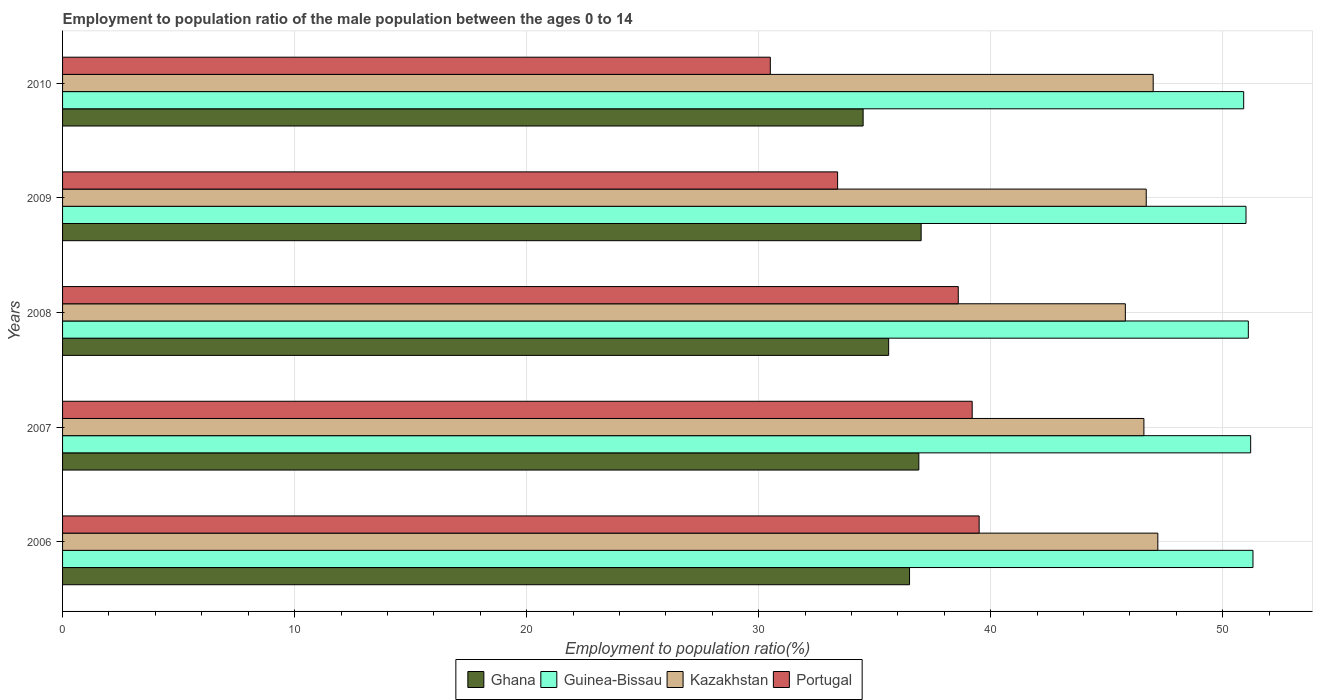How many bars are there on the 4th tick from the bottom?
Your answer should be compact. 4. What is the label of the 3rd group of bars from the top?
Your answer should be compact. 2008. What is the employment to population ratio in Ghana in 2010?
Keep it short and to the point. 34.5. Across all years, what is the maximum employment to population ratio in Ghana?
Your answer should be very brief. 37. Across all years, what is the minimum employment to population ratio in Kazakhstan?
Your answer should be compact. 45.8. In which year was the employment to population ratio in Kazakhstan maximum?
Offer a very short reply. 2006. What is the total employment to population ratio in Portugal in the graph?
Your answer should be compact. 181.2. What is the difference between the employment to population ratio in Guinea-Bissau in 2007 and that in 2008?
Give a very brief answer. 0.1. What is the difference between the employment to population ratio in Kazakhstan in 2009 and the employment to population ratio in Portugal in 2007?
Offer a terse response. 7.5. What is the average employment to population ratio in Portugal per year?
Ensure brevity in your answer.  36.24. In the year 2007, what is the difference between the employment to population ratio in Ghana and employment to population ratio in Kazakhstan?
Make the answer very short. -9.7. In how many years, is the employment to population ratio in Kazakhstan greater than 44 %?
Provide a succinct answer. 5. What is the ratio of the employment to population ratio in Kazakhstan in 2007 to that in 2010?
Give a very brief answer. 0.99. Is the difference between the employment to population ratio in Ghana in 2006 and 2010 greater than the difference between the employment to population ratio in Kazakhstan in 2006 and 2010?
Make the answer very short. Yes. What is the difference between the highest and the second highest employment to population ratio in Kazakhstan?
Keep it short and to the point. 0.2. What is the difference between the highest and the lowest employment to population ratio in Guinea-Bissau?
Your response must be concise. 0.4. Is it the case that in every year, the sum of the employment to population ratio in Portugal and employment to population ratio in Kazakhstan is greater than the sum of employment to population ratio in Guinea-Bissau and employment to population ratio in Ghana?
Your answer should be compact. No. What does the 3rd bar from the bottom in 2007 represents?
Give a very brief answer. Kazakhstan. Is it the case that in every year, the sum of the employment to population ratio in Kazakhstan and employment to population ratio in Guinea-Bissau is greater than the employment to population ratio in Portugal?
Your answer should be very brief. Yes. How many bars are there?
Your answer should be compact. 20. What is the difference between two consecutive major ticks on the X-axis?
Keep it short and to the point. 10. Does the graph contain any zero values?
Provide a short and direct response. No. Where does the legend appear in the graph?
Your response must be concise. Bottom center. How many legend labels are there?
Make the answer very short. 4. How are the legend labels stacked?
Give a very brief answer. Horizontal. What is the title of the graph?
Your answer should be compact. Employment to population ratio of the male population between the ages 0 to 14. Does "Fragile and conflict affected situations" appear as one of the legend labels in the graph?
Offer a terse response. No. What is the label or title of the X-axis?
Keep it short and to the point. Employment to population ratio(%). What is the Employment to population ratio(%) of Ghana in 2006?
Offer a very short reply. 36.5. What is the Employment to population ratio(%) of Guinea-Bissau in 2006?
Make the answer very short. 51.3. What is the Employment to population ratio(%) in Kazakhstan in 2006?
Keep it short and to the point. 47.2. What is the Employment to population ratio(%) of Portugal in 2006?
Keep it short and to the point. 39.5. What is the Employment to population ratio(%) in Ghana in 2007?
Your response must be concise. 36.9. What is the Employment to population ratio(%) of Guinea-Bissau in 2007?
Offer a very short reply. 51.2. What is the Employment to population ratio(%) of Kazakhstan in 2007?
Give a very brief answer. 46.6. What is the Employment to population ratio(%) in Portugal in 2007?
Offer a very short reply. 39.2. What is the Employment to population ratio(%) in Ghana in 2008?
Make the answer very short. 35.6. What is the Employment to population ratio(%) in Guinea-Bissau in 2008?
Provide a succinct answer. 51.1. What is the Employment to population ratio(%) in Kazakhstan in 2008?
Your response must be concise. 45.8. What is the Employment to population ratio(%) of Portugal in 2008?
Make the answer very short. 38.6. What is the Employment to population ratio(%) in Ghana in 2009?
Your answer should be very brief. 37. What is the Employment to population ratio(%) of Guinea-Bissau in 2009?
Your answer should be very brief. 51. What is the Employment to population ratio(%) of Kazakhstan in 2009?
Offer a terse response. 46.7. What is the Employment to population ratio(%) of Portugal in 2009?
Ensure brevity in your answer.  33.4. What is the Employment to population ratio(%) in Ghana in 2010?
Offer a very short reply. 34.5. What is the Employment to population ratio(%) in Guinea-Bissau in 2010?
Provide a succinct answer. 50.9. What is the Employment to population ratio(%) of Portugal in 2010?
Offer a terse response. 30.5. Across all years, what is the maximum Employment to population ratio(%) of Ghana?
Give a very brief answer. 37. Across all years, what is the maximum Employment to population ratio(%) of Guinea-Bissau?
Your answer should be compact. 51.3. Across all years, what is the maximum Employment to population ratio(%) in Kazakhstan?
Offer a terse response. 47.2. Across all years, what is the maximum Employment to population ratio(%) of Portugal?
Ensure brevity in your answer.  39.5. Across all years, what is the minimum Employment to population ratio(%) of Ghana?
Ensure brevity in your answer.  34.5. Across all years, what is the minimum Employment to population ratio(%) of Guinea-Bissau?
Your answer should be compact. 50.9. Across all years, what is the minimum Employment to population ratio(%) of Kazakhstan?
Your response must be concise. 45.8. Across all years, what is the minimum Employment to population ratio(%) in Portugal?
Ensure brevity in your answer.  30.5. What is the total Employment to population ratio(%) of Ghana in the graph?
Make the answer very short. 180.5. What is the total Employment to population ratio(%) of Guinea-Bissau in the graph?
Ensure brevity in your answer.  255.5. What is the total Employment to population ratio(%) of Kazakhstan in the graph?
Provide a succinct answer. 233.3. What is the total Employment to population ratio(%) in Portugal in the graph?
Ensure brevity in your answer.  181.2. What is the difference between the Employment to population ratio(%) of Ghana in 2006 and that in 2009?
Offer a very short reply. -0.5. What is the difference between the Employment to population ratio(%) in Guinea-Bissau in 2006 and that in 2009?
Keep it short and to the point. 0.3. What is the difference between the Employment to population ratio(%) of Portugal in 2006 and that in 2009?
Ensure brevity in your answer.  6.1. What is the difference between the Employment to population ratio(%) of Portugal in 2006 and that in 2010?
Offer a very short reply. 9. What is the difference between the Employment to population ratio(%) in Ghana in 2007 and that in 2008?
Make the answer very short. 1.3. What is the difference between the Employment to population ratio(%) in Kazakhstan in 2007 and that in 2008?
Provide a succinct answer. 0.8. What is the difference between the Employment to population ratio(%) in Portugal in 2007 and that in 2008?
Keep it short and to the point. 0.6. What is the difference between the Employment to population ratio(%) in Ghana in 2007 and that in 2009?
Provide a short and direct response. -0.1. What is the difference between the Employment to population ratio(%) of Guinea-Bissau in 2007 and that in 2009?
Your answer should be very brief. 0.2. What is the difference between the Employment to population ratio(%) of Portugal in 2007 and that in 2009?
Your answer should be compact. 5.8. What is the difference between the Employment to population ratio(%) in Ghana in 2007 and that in 2010?
Your answer should be very brief. 2.4. What is the difference between the Employment to population ratio(%) of Guinea-Bissau in 2007 and that in 2010?
Keep it short and to the point. 0.3. What is the difference between the Employment to population ratio(%) of Kazakhstan in 2007 and that in 2010?
Offer a very short reply. -0.4. What is the difference between the Employment to population ratio(%) in Portugal in 2007 and that in 2010?
Make the answer very short. 8.7. What is the difference between the Employment to population ratio(%) in Portugal in 2008 and that in 2009?
Your response must be concise. 5.2. What is the difference between the Employment to population ratio(%) of Kazakhstan in 2008 and that in 2010?
Offer a very short reply. -1.2. What is the difference between the Employment to population ratio(%) in Ghana in 2009 and that in 2010?
Your response must be concise. 2.5. What is the difference between the Employment to population ratio(%) in Guinea-Bissau in 2009 and that in 2010?
Provide a succinct answer. 0.1. What is the difference between the Employment to population ratio(%) in Ghana in 2006 and the Employment to population ratio(%) in Guinea-Bissau in 2007?
Offer a very short reply. -14.7. What is the difference between the Employment to population ratio(%) in Ghana in 2006 and the Employment to population ratio(%) in Kazakhstan in 2007?
Offer a terse response. -10.1. What is the difference between the Employment to population ratio(%) of Ghana in 2006 and the Employment to population ratio(%) of Portugal in 2007?
Make the answer very short. -2.7. What is the difference between the Employment to population ratio(%) in Kazakhstan in 2006 and the Employment to population ratio(%) in Portugal in 2007?
Make the answer very short. 8. What is the difference between the Employment to population ratio(%) in Ghana in 2006 and the Employment to population ratio(%) in Guinea-Bissau in 2008?
Offer a terse response. -14.6. What is the difference between the Employment to population ratio(%) of Ghana in 2006 and the Employment to population ratio(%) of Kazakhstan in 2008?
Ensure brevity in your answer.  -9.3. What is the difference between the Employment to population ratio(%) of Ghana in 2006 and the Employment to population ratio(%) of Portugal in 2008?
Offer a terse response. -2.1. What is the difference between the Employment to population ratio(%) in Ghana in 2006 and the Employment to population ratio(%) in Guinea-Bissau in 2009?
Offer a very short reply. -14.5. What is the difference between the Employment to population ratio(%) of Ghana in 2006 and the Employment to population ratio(%) of Portugal in 2009?
Keep it short and to the point. 3.1. What is the difference between the Employment to population ratio(%) in Guinea-Bissau in 2006 and the Employment to population ratio(%) in Portugal in 2009?
Provide a succinct answer. 17.9. What is the difference between the Employment to population ratio(%) of Kazakhstan in 2006 and the Employment to population ratio(%) of Portugal in 2009?
Provide a succinct answer. 13.8. What is the difference between the Employment to population ratio(%) of Ghana in 2006 and the Employment to population ratio(%) of Guinea-Bissau in 2010?
Make the answer very short. -14.4. What is the difference between the Employment to population ratio(%) in Guinea-Bissau in 2006 and the Employment to population ratio(%) in Portugal in 2010?
Your answer should be compact. 20.8. What is the difference between the Employment to population ratio(%) in Kazakhstan in 2006 and the Employment to population ratio(%) in Portugal in 2010?
Keep it short and to the point. 16.7. What is the difference between the Employment to population ratio(%) of Ghana in 2007 and the Employment to population ratio(%) of Kazakhstan in 2008?
Offer a terse response. -8.9. What is the difference between the Employment to population ratio(%) in Ghana in 2007 and the Employment to population ratio(%) in Portugal in 2008?
Your answer should be compact. -1.7. What is the difference between the Employment to population ratio(%) in Guinea-Bissau in 2007 and the Employment to population ratio(%) in Kazakhstan in 2008?
Make the answer very short. 5.4. What is the difference between the Employment to population ratio(%) of Kazakhstan in 2007 and the Employment to population ratio(%) of Portugal in 2008?
Provide a succinct answer. 8. What is the difference between the Employment to population ratio(%) of Ghana in 2007 and the Employment to population ratio(%) of Guinea-Bissau in 2009?
Give a very brief answer. -14.1. What is the difference between the Employment to population ratio(%) of Ghana in 2007 and the Employment to population ratio(%) of Portugal in 2009?
Make the answer very short. 3.5. What is the difference between the Employment to population ratio(%) in Guinea-Bissau in 2007 and the Employment to population ratio(%) in Portugal in 2009?
Offer a terse response. 17.8. What is the difference between the Employment to population ratio(%) in Ghana in 2007 and the Employment to population ratio(%) in Portugal in 2010?
Ensure brevity in your answer.  6.4. What is the difference between the Employment to population ratio(%) of Guinea-Bissau in 2007 and the Employment to population ratio(%) of Portugal in 2010?
Offer a terse response. 20.7. What is the difference between the Employment to population ratio(%) of Ghana in 2008 and the Employment to population ratio(%) of Guinea-Bissau in 2009?
Give a very brief answer. -15.4. What is the difference between the Employment to population ratio(%) of Ghana in 2008 and the Employment to population ratio(%) of Portugal in 2009?
Provide a succinct answer. 2.2. What is the difference between the Employment to population ratio(%) in Ghana in 2008 and the Employment to population ratio(%) in Guinea-Bissau in 2010?
Provide a succinct answer. -15.3. What is the difference between the Employment to population ratio(%) in Guinea-Bissau in 2008 and the Employment to population ratio(%) in Kazakhstan in 2010?
Provide a succinct answer. 4.1. What is the difference between the Employment to population ratio(%) in Guinea-Bissau in 2008 and the Employment to population ratio(%) in Portugal in 2010?
Keep it short and to the point. 20.6. What is the difference between the Employment to population ratio(%) in Ghana in 2009 and the Employment to population ratio(%) in Kazakhstan in 2010?
Your response must be concise. -10. What is the difference between the Employment to population ratio(%) of Guinea-Bissau in 2009 and the Employment to population ratio(%) of Kazakhstan in 2010?
Give a very brief answer. 4. What is the difference between the Employment to population ratio(%) in Kazakhstan in 2009 and the Employment to population ratio(%) in Portugal in 2010?
Give a very brief answer. 16.2. What is the average Employment to population ratio(%) of Ghana per year?
Provide a short and direct response. 36.1. What is the average Employment to population ratio(%) of Guinea-Bissau per year?
Give a very brief answer. 51.1. What is the average Employment to population ratio(%) in Kazakhstan per year?
Offer a terse response. 46.66. What is the average Employment to population ratio(%) in Portugal per year?
Make the answer very short. 36.24. In the year 2006, what is the difference between the Employment to population ratio(%) in Ghana and Employment to population ratio(%) in Guinea-Bissau?
Provide a succinct answer. -14.8. In the year 2006, what is the difference between the Employment to population ratio(%) in Ghana and Employment to population ratio(%) in Kazakhstan?
Provide a succinct answer. -10.7. In the year 2006, what is the difference between the Employment to population ratio(%) of Guinea-Bissau and Employment to population ratio(%) of Kazakhstan?
Provide a short and direct response. 4.1. In the year 2006, what is the difference between the Employment to population ratio(%) in Kazakhstan and Employment to population ratio(%) in Portugal?
Your answer should be very brief. 7.7. In the year 2007, what is the difference between the Employment to population ratio(%) in Ghana and Employment to population ratio(%) in Guinea-Bissau?
Keep it short and to the point. -14.3. In the year 2007, what is the difference between the Employment to population ratio(%) in Ghana and Employment to population ratio(%) in Portugal?
Ensure brevity in your answer.  -2.3. In the year 2007, what is the difference between the Employment to population ratio(%) in Guinea-Bissau and Employment to population ratio(%) in Kazakhstan?
Provide a succinct answer. 4.6. In the year 2007, what is the difference between the Employment to population ratio(%) of Guinea-Bissau and Employment to population ratio(%) of Portugal?
Make the answer very short. 12. In the year 2008, what is the difference between the Employment to population ratio(%) of Ghana and Employment to population ratio(%) of Guinea-Bissau?
Your answer should be very brief. -15.5. In the year 2008, what is the difference between the Employment to population ratio(%) of Ghana and Employment to population ratio(%) of Kazakhstan?
Make the answer very short. -10.2. In the year 2008, what is the difference between the Employment to population ratio(%) in Ghana and Employment to population ratio(%) in Portugal?
Provide a succinct answer. -3. In the year 2008, what is the difference between the Employment to population ratio(%) of Guinea-Bissau and Employment to population ratio(%) of Kazakhstan?
Offer a very short reply. 5.3. In the year 2008, what is the difference between the Employment to population ratio(%) in Kazakhstan and Employment to population ratio(%) in Portugal?
Your answer should be very brief. 7.2. In the year 2009, what is the difference between the Employment to population ratio(%) in Ghana and Employment to population ratio(%) in Guinea-Bissau?
Give a very brief answer. -14. In the year 2009, what is the difference between the Employment to population ratio(%) of Ghana and Employment to population ratio(%) of Kazakhstan?
Give a very brief answer. -9.7. In the year 2009, what is the difference between the Employment to population ratio(%) in Ghana and Employment to population ratio(%) in Portugal?
Your response must be concise. 3.6. In the year 2009, what is the difference between the Employment to population ratio(%) in Guinea-Bissau and Employment to population ratio(%) in Portugal?
Make the answer very short. 17.6. In the year 2009, what is the difference between the Employment to population ratio(%) of Kazakhstan and Employment to population ratio(%) of Portugal?
Make the answer very short. 13.3. In the year 2010, what is the difference between the Employment to population ratio(%) of Ghana and Employment to population ratio(%) of Guinea-Bissau?
Ensure brevity in your answer.  -16.4. In the year 2010, what is the difference between the Employment to population ratio(%) in Ghana and Employment to population ratio(%) in Portugal?
Give a very brief answer. 4. In the year 2010, what is the difference between the Employment to population ratio(%) of Guinea-Bissau and Employment to population ratio(%) of Portugal?
Give a very brief answer. 20.4. What is the ratio of the Employment to population ratio(%) of Ghana in 2006 to that in 2007?
Give a very brief answer. 0.99. What is the ratio of the Employment to population ratio(%) of Kazakhstan in 2006 to that in 2007?
Ensure brevity in your answer.  1.01. What is the ratio of the Employment to population ratio(%) in Portugal in 2006 to that in 2007?
Offer a very short reply. 1.01. What is the ratio of the Employment to population ratio(%) of Ghana in 2006 to that in 2008?
Your response must be concise. 1.03. What is the ratio of the Employment to population ratio(%) in Kazakhstan in 2006 to that in 2008?
Your answer should be very brief. 1.03. What is the ratio of the Employment to population ratio(%) of Portugal in 2006 to that in 2008?
Provide a short and direct response. 1.02. What is the ratio of the Employment to population ratio(%) of Ghana in 2006 to that in 2009?
Your answer should be very brief. 0.99. What is the ratio of the Employment to population ratio(%) in Guinea-Bissau in 2006 to that in 2009?
Make the answer very short. 1.01. What is the ratio of the Employment to population ratio(%) of Kazakhstan in 2006 to that in 2009?
Offer a very short reply. 1.01. What is the ratio of the Employment to population ratio(%) in Portugal in 2006 to that in 2009?
Your answer should be compact. 1.18. What is the ratio of the Employment to population ratio(%) in Ghana in 2006 to that in 2010?
Your answer should be compact. 1.06. What is the ratio of the Employment to population ratio(%) of Guinea-Bissau in 2006 to that in 2010?
Give a very brief answer. 1.01. What is the ratio of the Employment to population ratio(%) in Kazakhstan in 2006 to that in 2010?
Your answer should be very brief. 1. What is the ratio of the Employment to population ratio(%) in Portugal in 2006 to that in 2010?
Your answer should be very brief. 1.3. What is the ratio of the Employment to population ratio(%) of Ghana in 2007 to that in 2008?
Offer a terse response. 1.04. What is the ratio of the Employment to population ratio(%) of Kazakhstan in 2007 to that in 2008?
Provide a succinct answer. 1.02. What is the ratio of the Employment to population ratio(%) of Portugal in 2007 to that in 2008?
Give a very brief answer. 1.02. What is the ratio of the Employment to population ratio(%) of Ghana in 2007 to that in 2009?
Make the answer very short. 1. What is the ratio of the Employment to population ratio(%) of Portugal in 2007 to that in 2009?
Make the answer very short. 1.17. What is the ratio of the Employment to population ratio(%) in Ghana in 2007 to that in 2010?
Your answer should be compact. 1.07. What is the ratio of the Employment to population ratio(%) of Guinea-Bissau in 2007 to that in 2010?
Your answer should be compact. 1.01. What is the ratio of the Employment to population ratio(%) of Kazakhstan in 2007 to that in 2010?
Your answer should be very brief. 0.99. What is the ratio of the Employment to population ratio(%) of Portugal in 2007 to that in 2010?
Provide a short and direct response. 1.29. What is the ratio of the Employment to population ratio(%) in Ghana in 2008 to that in 2009?
Keep it short and to the point. 0.96. What is the ratio of the Employment to population ratio(%) of Guinea-Bissau in 2008 to that in 2009?
Offer a very short reply. 1. What is the ratio of the Employment to population ratio(%) in Kazakhstan in 2008 to that in 2009?
Offer a terse response. 0.98. What is the ratio of the Employment to population ratio(%) in Portugal in 2008 to that in 2009?
Offer a very short reply. 1.16. What is the ratio of the Employment to population ratio(%) of Ghana in 2008 to that in 2010?
Give a very brief answer. 1.03. What is the ratio of the Employment to population ratio(%) of Guinea-Bissau in 2008 to that in 2010?
Provide a succinct answer. 1. What is the ratio of the Employment to population ratio(%) in Kazakhstan in 2008 to that in 2010?
Your answer should be very brief. 0.97. What is the ratio of the Employment to population ratio(%) of Portugal in 2008 to that in 2010?
Your answer should be compact. 1.27. What is the ratio of the Employment to population ratio(%) of Ghana in 2009 to that in 2010?
Provide a short and direct response. 1.07. What is the ratio of the Employment to population ratio(%) of Kazakhstan in 2009 to that in 2010?
Your response must be concise. 0.99. What is the ratio of the Employment to population ratio(%) of Portugal in 2009 to that in 2010?
Make the answer very short. 1.1. What is the difference between the highest and the second highest Employment to population ratio(%) of Kazakhstan?
Ensure brevity in your answer.  0.2. What is the difference between the highest and the second highest Employment to population ratio(%) in Portugal?
Give a very brief answer. 0.3. What is the difference between the highest and the lowest Employment to population ratio(%) in Kazakhstan?
Keep it short and to the point. 1.4. What is the difference between the highest and the lowest Employment to population ratio(%) in Portugal?
Your response must be concise. 9. 